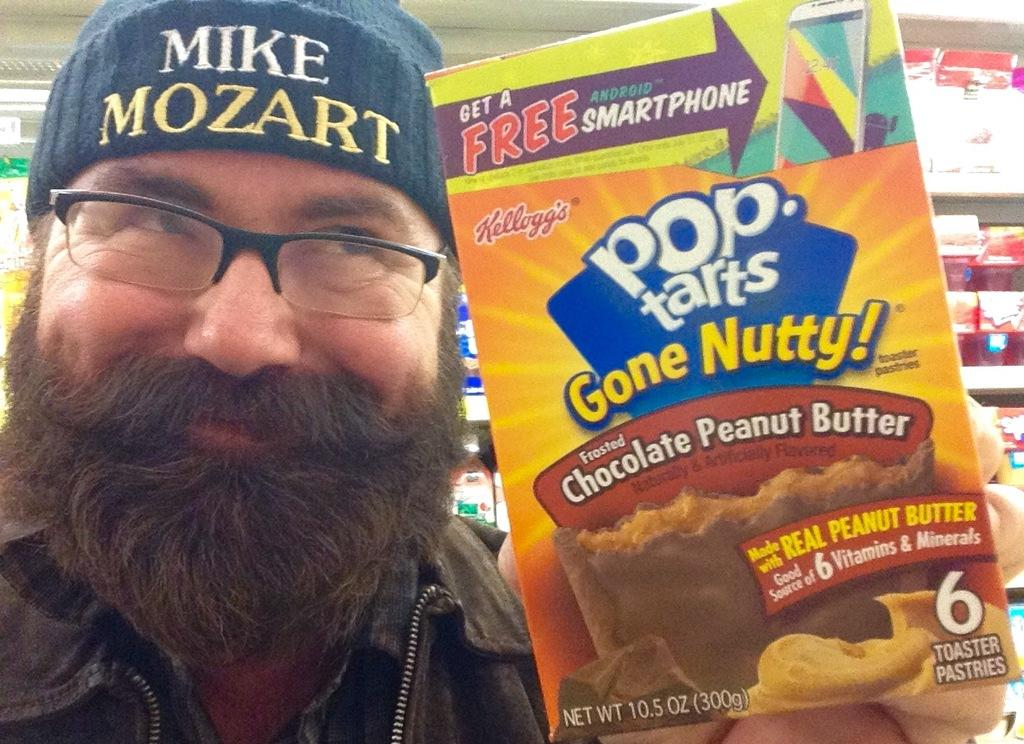Who is the main subject in the image? There is a man in the image. What is the man holding in his hand? The man is holding a packaged good in his hand. What type of rake is the man using to perform in the image? There is no rake present in the image, and the man is not performing. 